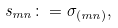<formula> <loc_0><loc_0><loc_500><loc_500>s _ { m n } \colon = \sigma _ { ( m n ) } ,</formula> 